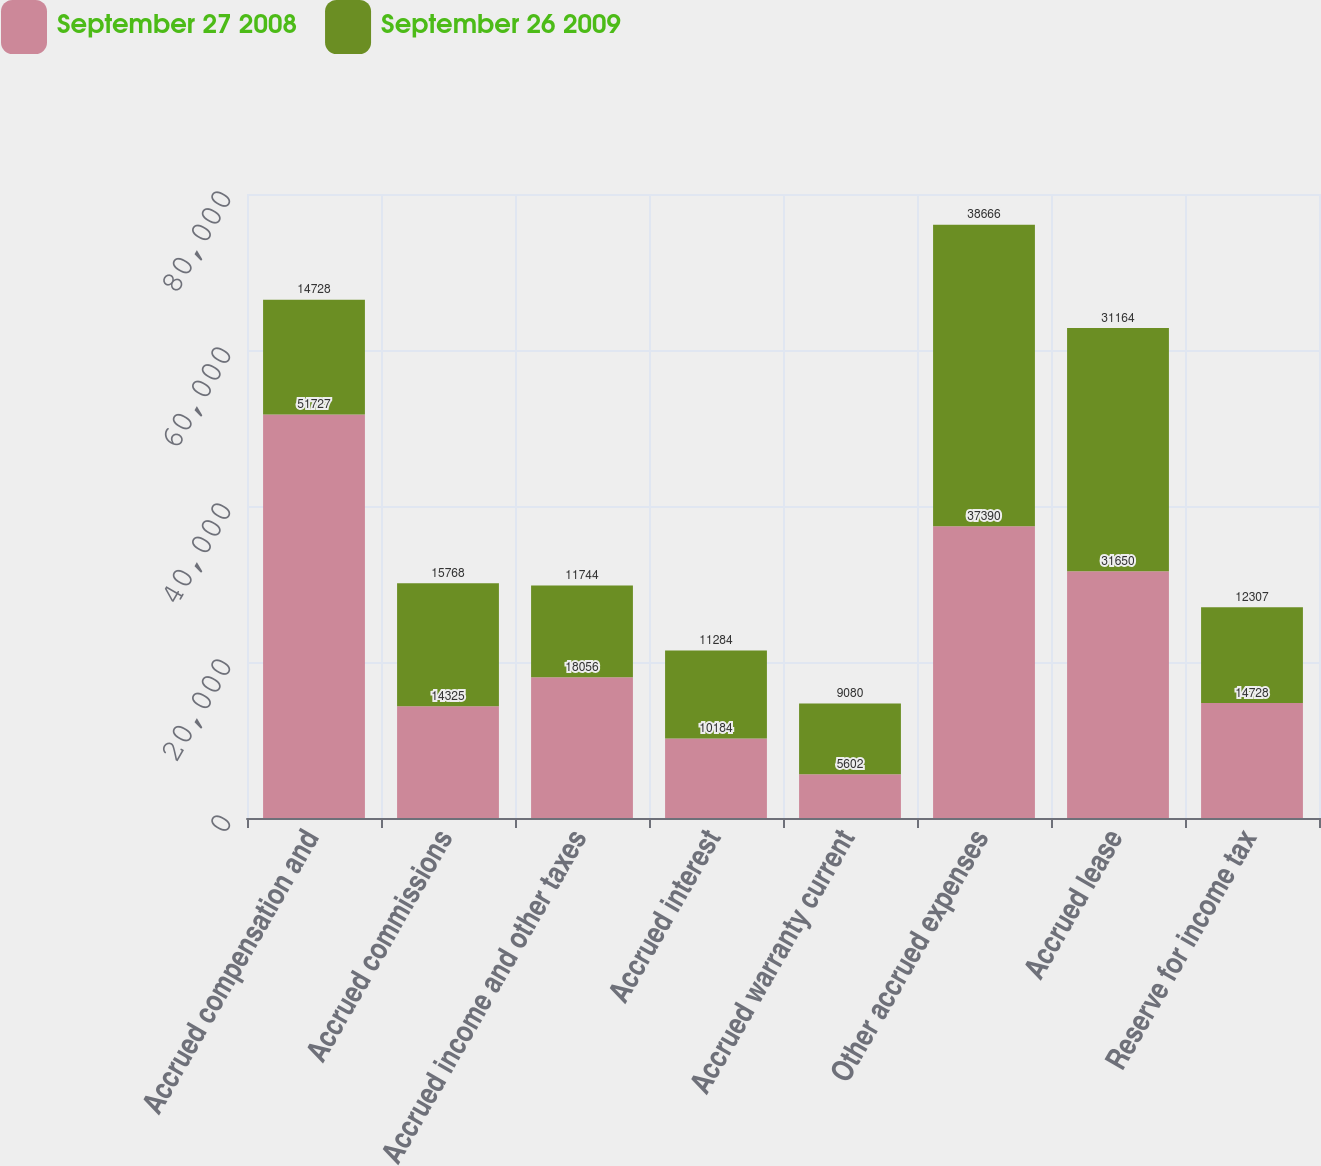Convert chart to OTSL. <chart><loc_0><loc_0><loc_500><loc_500><stacked_bar_chart><ecel><fcel>Accrued compensation and<fcel>Accrued commissions<fcel>Accrued income and other taxes<fcel>Accrued interest<fcel>Accrued warranty current<fcel>Other accrued expenses<fcel>Accrued lease<fcel>Reserve for income tax<nl><fcel>September 27 2008<fcel>51727<fcel>14325<fcel>18056<fcel>10184<fcel>5602<fcel>37390<fcel>31650<fcel>14728<nl><fcel>September 26 2009<fcel>14728<fcel>15768<fcel>11744<fcel>11284<fcel>9080<fcel>38666<fcel>31164<fcel>12307<nl></chart> 